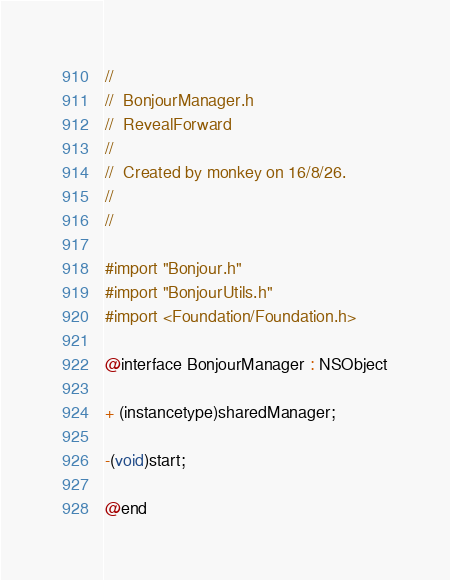<code> <loc_0><loc_0><loc_500><loc_500><_C_>//
//  BonjourManager.h
//  RevealForward
//
//  Created by monkey on 16/8/26.
//
//

#import "Bonjour.h"
#import "BonjourUtils.h"
#import <Foundation/Foundation.h>

@interface BonjourManager : NSObject

+ (instancetype)sharedManager;

-(void)start;

@end
</code> 